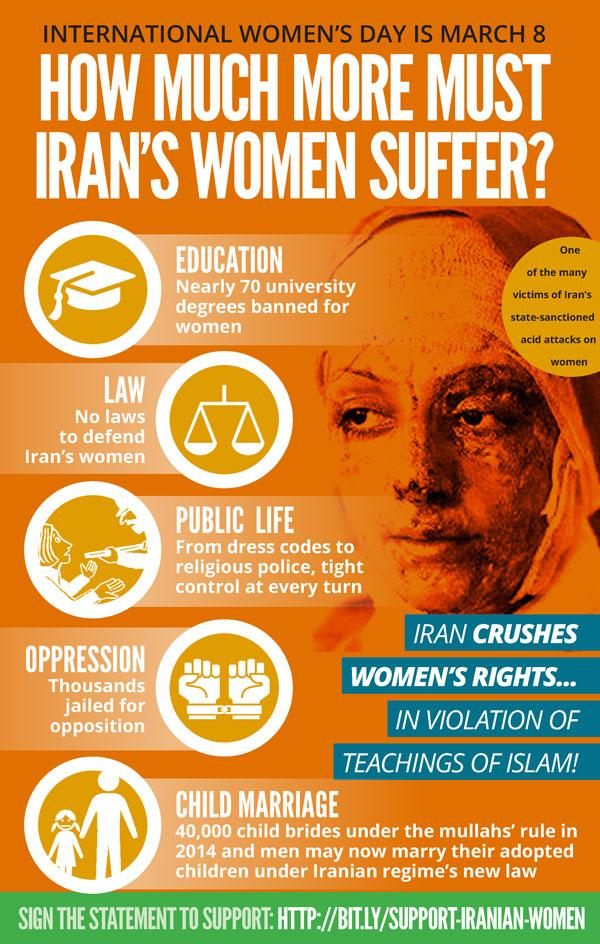Highlight a few significant elements in this photo. Thousands of women have been jailed for their opposition. The graphic depicts a victim of acid attacks on women. 